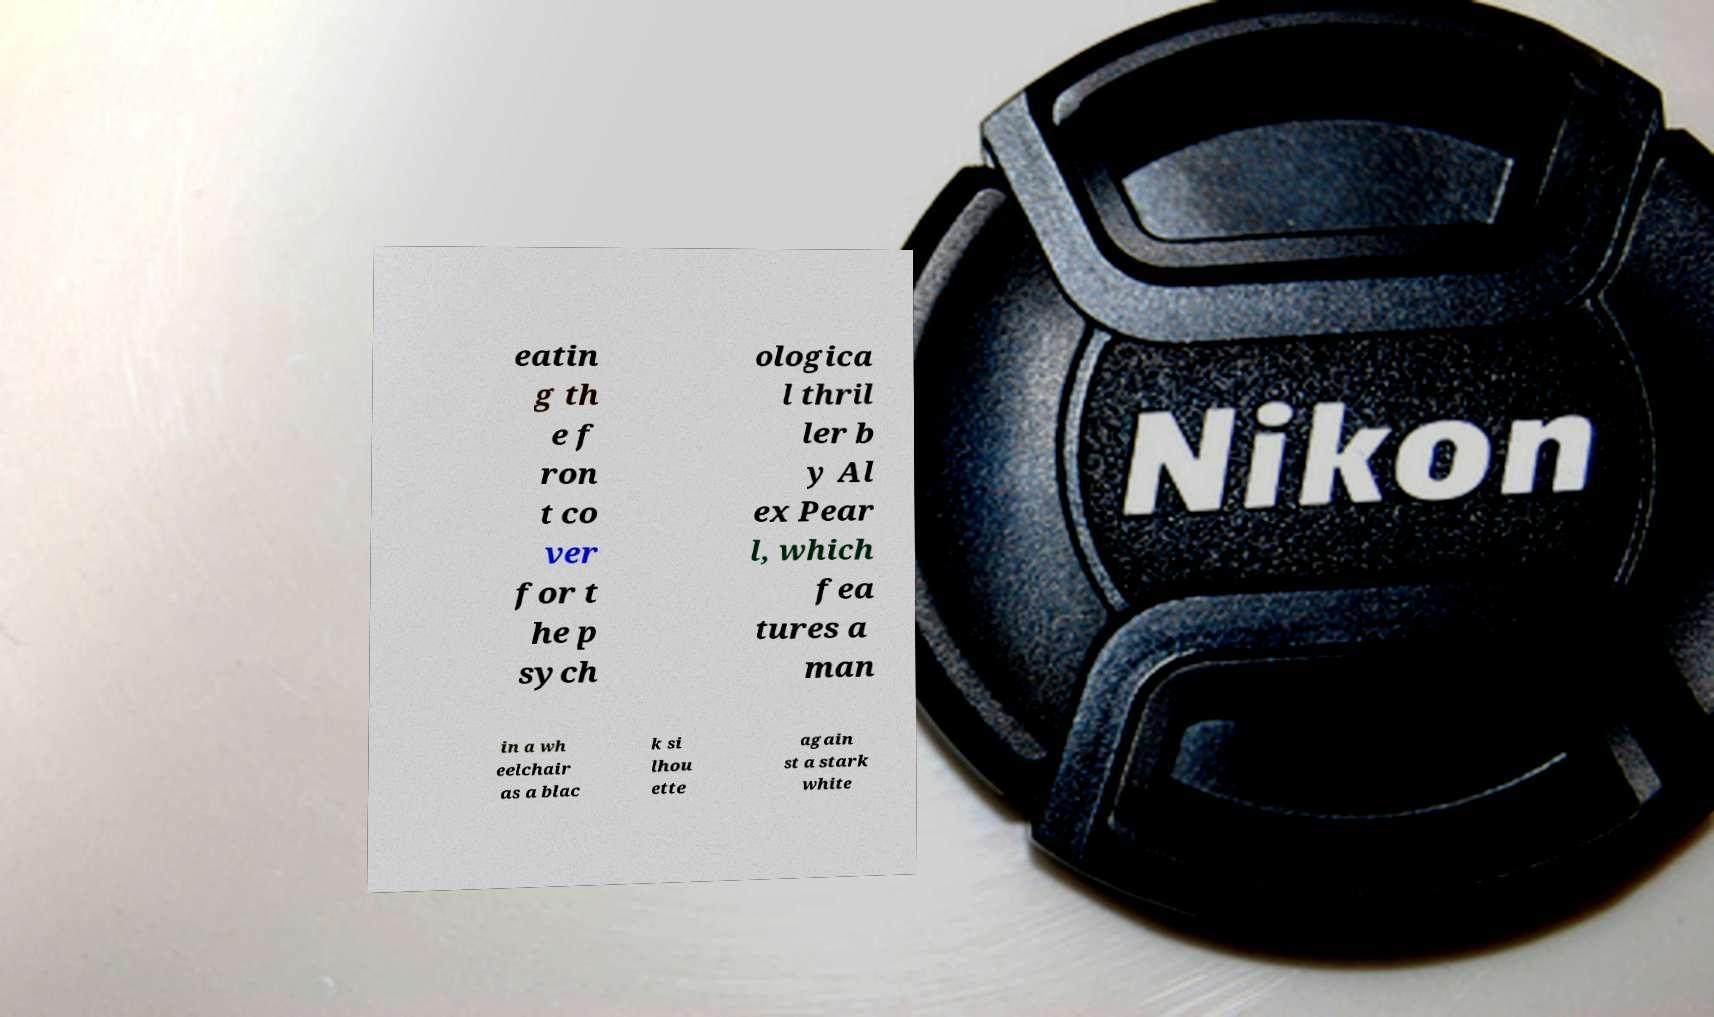Could you extract and type out the text from this image? eatin g th e f ron t co ver for t he p sych ologica l thril ler b y Al ex Pear l, which fea tures a man in a wh eelchair as a blac k si lhou ette again st a stark white 